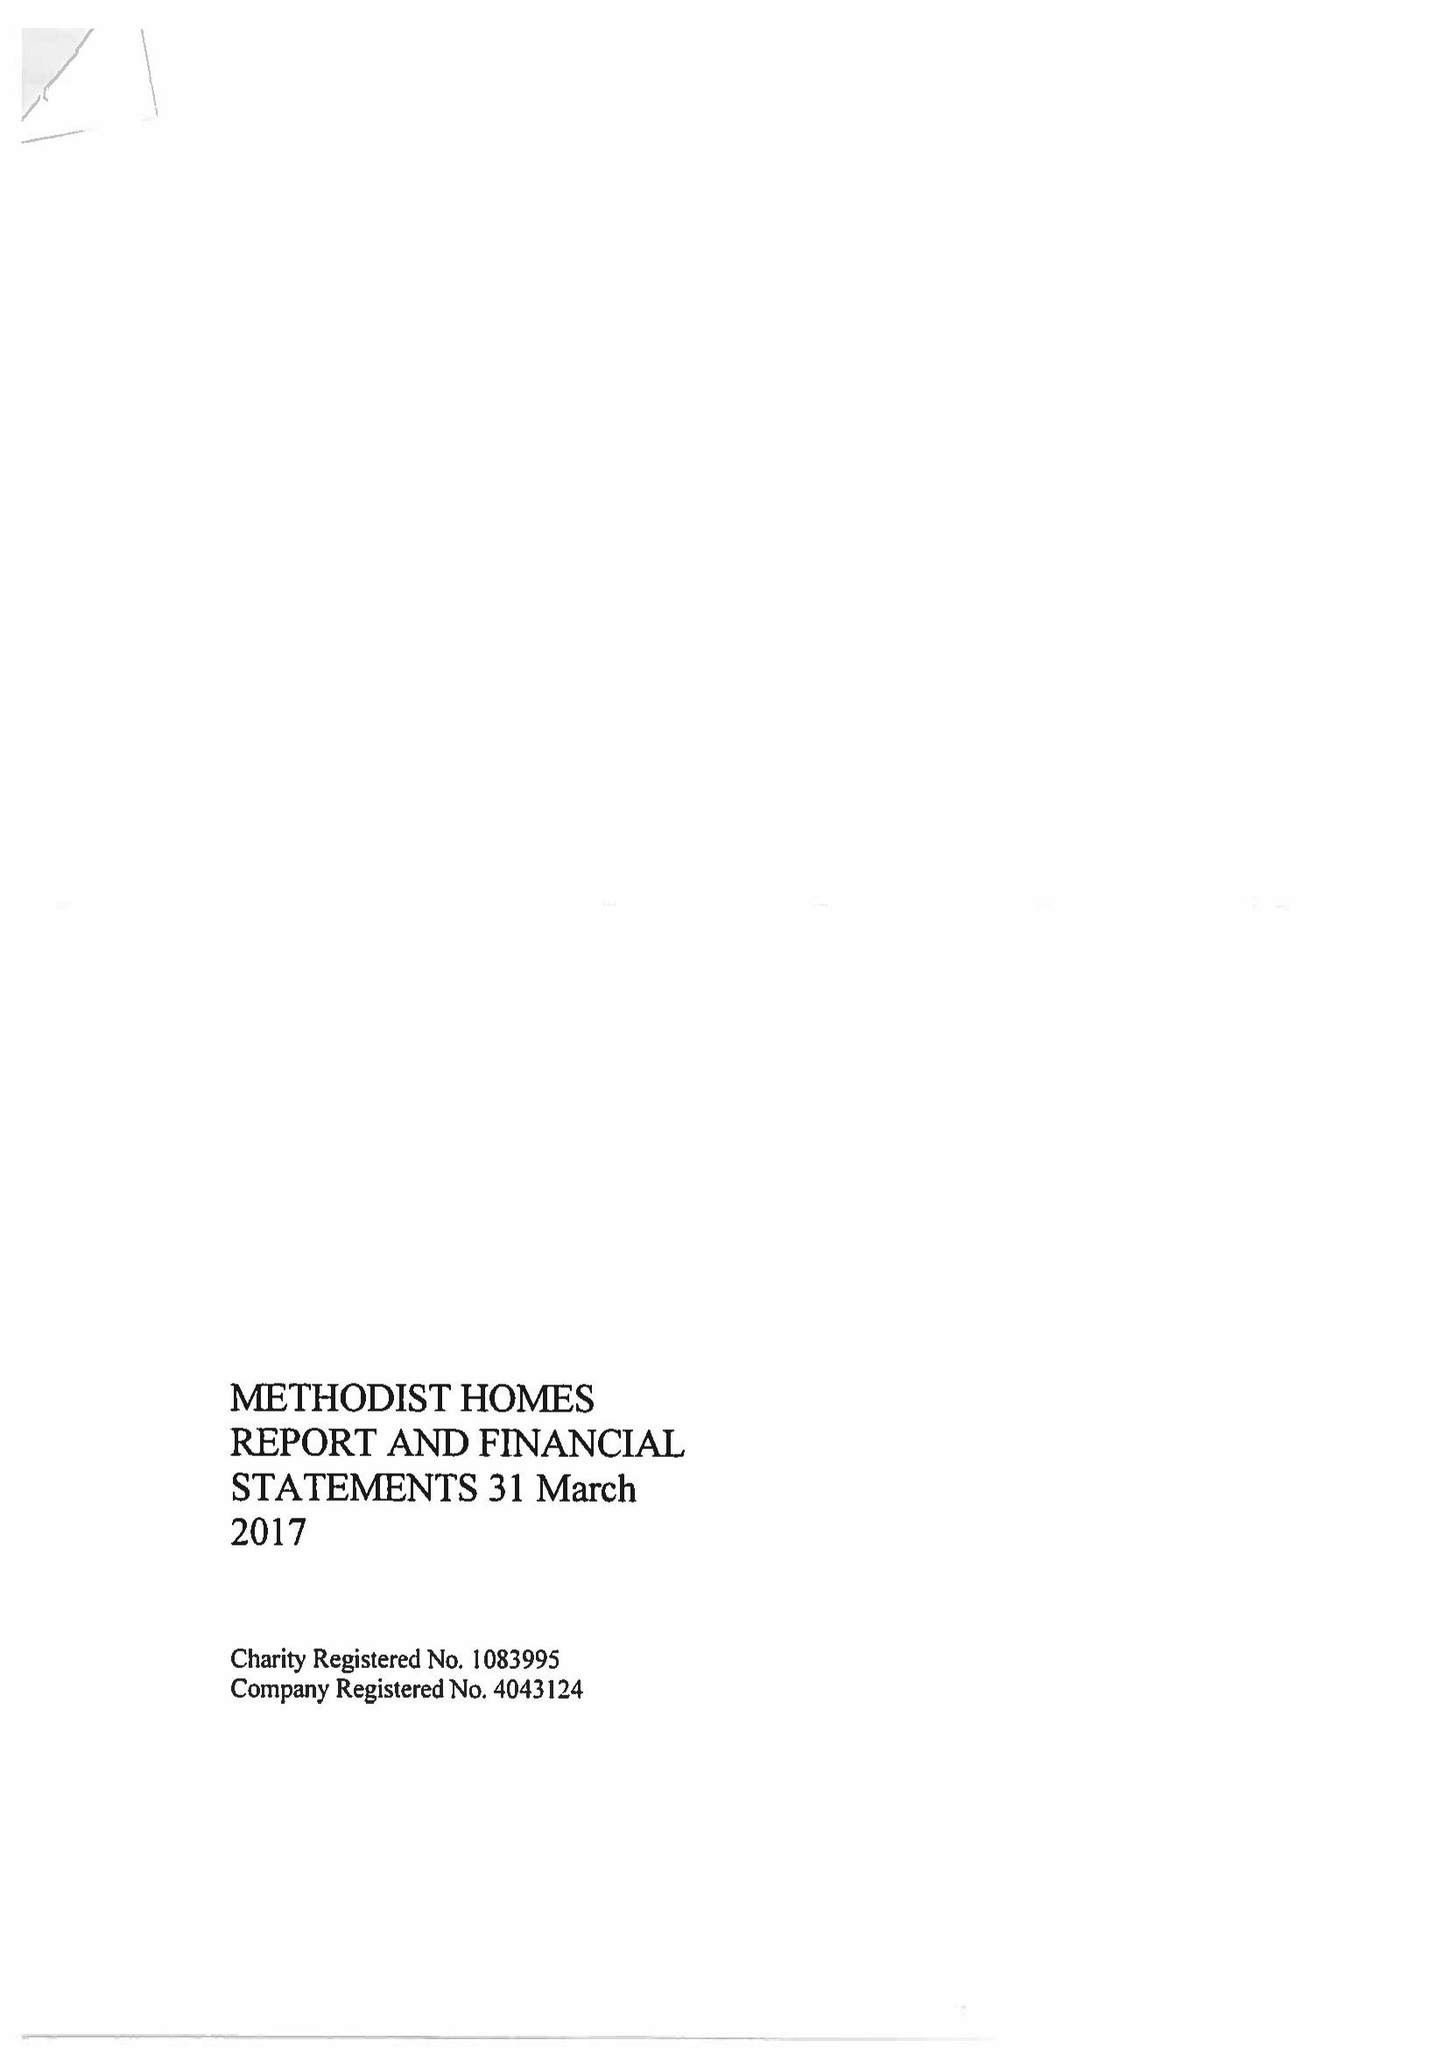What is the value for the address__street_line?
Answer the question using a single word or phrase. STUART STREET 